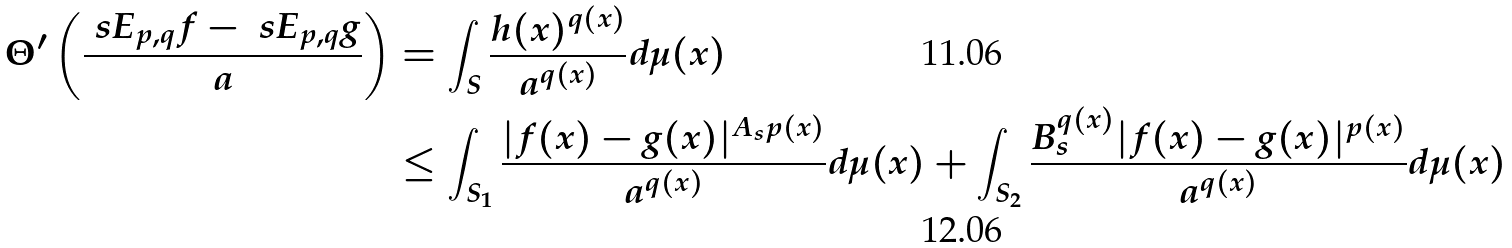Convert formula to latex. <formula><loc_0><loc_0><loc_500><loc_500>\Theta ^ { \prime } \left ( \frac { \ s E _ { p , q } f - \ s E _ { p , q } g } { a } \right ) & = \int _ { S } \frac { h ( x ) ^ { q ( x ) } } { a ^ { q ( x ) } } d \mu ( x ) \\ & \leq \int _ { S _ { 1 } } \frac { | f ( x ) - g ( x ) | ^ { A _ { s } p ( x ) } } { a ^ { q ( x ) } } d \mu ( x ) + \int _ { S _ { 2 } } \frac { B _ { s } ^ { q ( x ) } | f ( x ) - g ( x ) | ^ { p ( x ) } } { a ^ { q ( x ) } } d \mu ( x )</formula> 